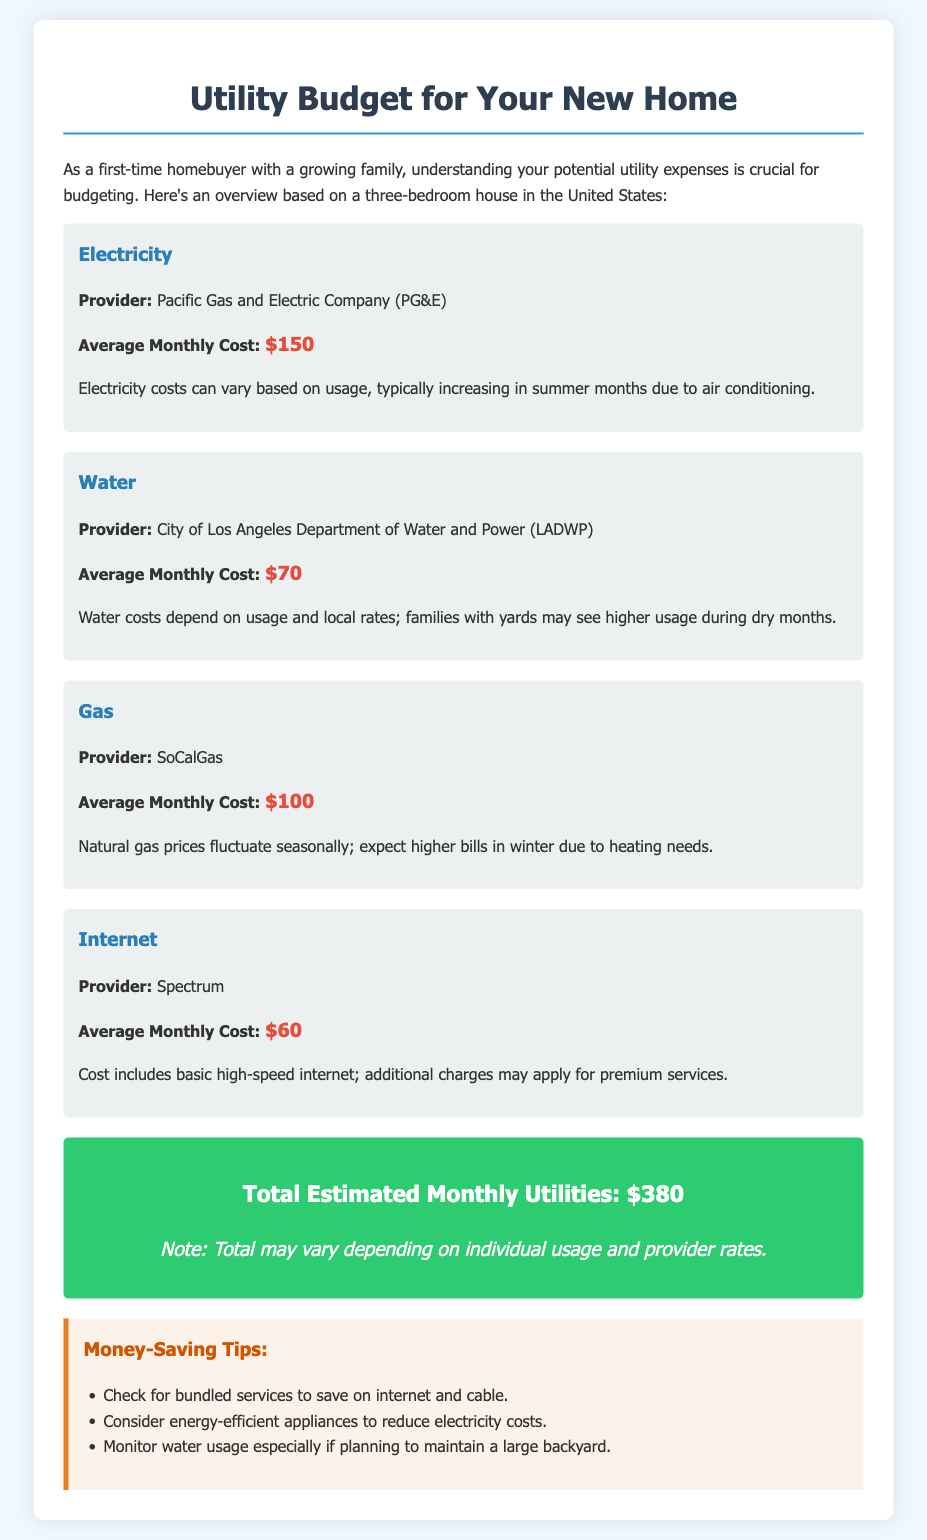What is the average monthly cost of electricity? The document states that the average monthly cost of electricity is $150.
Answer: $150 Who is the provider for water utilities? According to the document, the provider for water utilities is the City of Los Angeles Department of Water and Power (LADWP).
Answer: City of Los Angeles Department of Water and Power (LADWP) What is the total estimated monthly utilities cost? The total estimated monthly utilities cost is provided as $380 in the document.
Answer: $380 Which utility has the highest average monthly cost? The document lists electricity as having the highest average monthly cost at $150.
Answer: Electricity How does water usage relate to families with yards? The document mentions that families with yards may see higher water usage during dry months.
Answer: Higher usage during dry months What tips are provided for saving money on utilities? One tip provided in the document is to check for bundled services to save on internet and cable.
Answer: Check for bundled services to save on internet and cable What is the average monthly cost of gas? The document indicates that the average monthly cost of gas is $100.
Answer: $100 What can increase electricity costs according to the document? The document states that electricity costs can increase due to air conditioning usage in summer months.
Answer: Air conditioning usage in summer months Which provider offers internet services as mentioned in the document? Spectrum is mentioned as the provider offering internet services in the document.
Answer: Spectrum 